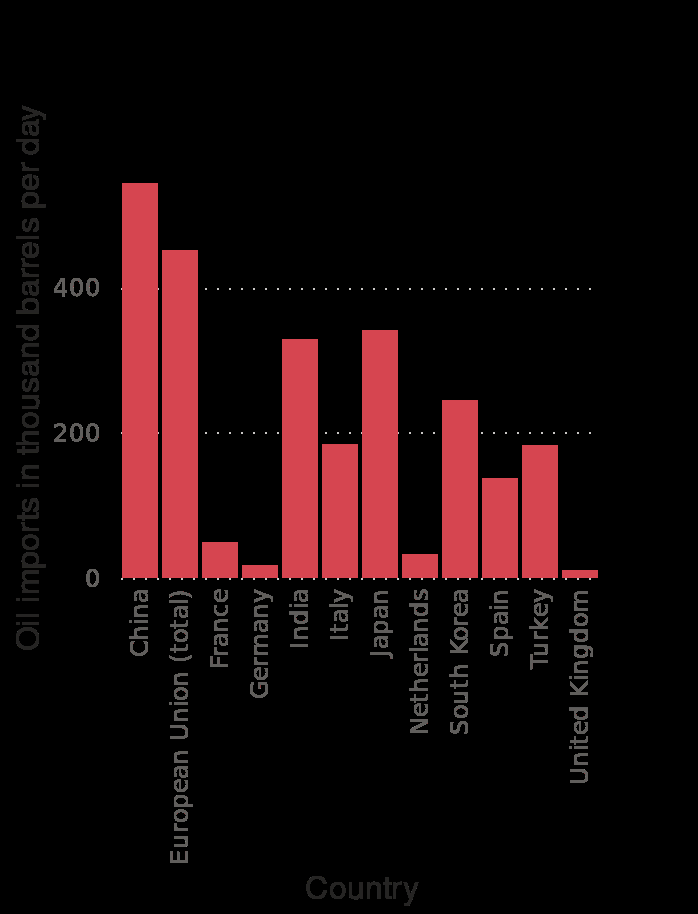<image>
What does the y-axis of the bar chart represent? The y-axis of the bar chart represents the oil imports in thousand barrels per day. 